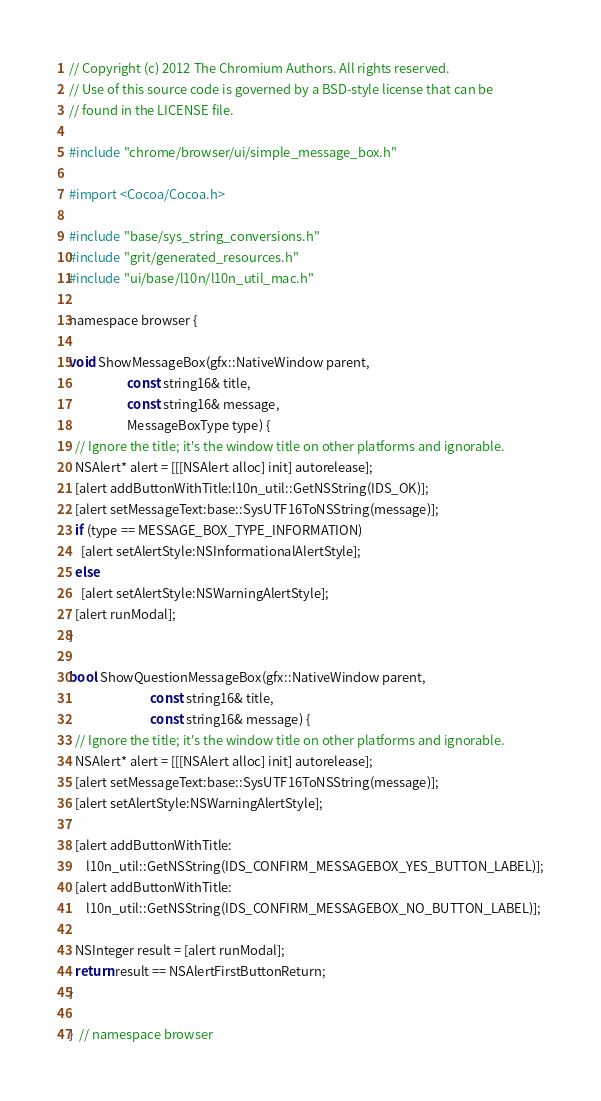Convert code to text. <code><loc_0><loc_0><loc_500><loc_500><_ObjectiveC_>// Copyright (c) 2012 The Chromium Authors. All rights reserved.
// Use of this source code is governed by a BSD-style license that can be
// found in the LICENSE file.

#include "chrome/browser/ui/simple_message_box.h"

#import <Cocoa/Cocoa.h>

#include "base/sys_string_conversions.h"
#include "grit/generated_resources.h"
#include "ui/base/l10n/l10n_util_mac.h"

namespace browser {

void ShowMessageBox(gfx::NativeWindow parent,
                    const string16& title,
                    const string16& message,
                    MessageBoxType type) {
  // Ignore the title; it's the window title on other platforms and ignorable.
  NSAlert* alert = [[[NSAlert alloc] init] autorelease];
  [alert addButtonWithTitle:l10n_util::GetNSString(IDS_OK)];
  [alert setMessageText:base::SysUTF16ToNSString(message)];
  if (type == MESSAGE_BOX_TYPE_INFORMATION)
    [alert setAlertStyle:NSInformationalAlertStyle];
  else
    [alert setAlertStyle:NSWarningAlertStyle];
  [alert runModal];
}

bool ShowQuestionMessageBox(gfx::NativeWindow parent,
                            const string16& title,
                            const string16& message) {
  // Ignore the title; it's the window title on other platforms and ignorable.
  NSAlert* alert = [[[NSAlert alloc] init] autorelease];
  [alert setMessageText:base::SysUTF16ToNSString(message)];
  [alert setAlertStyle:NSWarningAlertStyle];

  [alert addButtonWithTitle:
      l10n_util::GetNSString(IDS_CONFIRM_MESSAGEBOX_YES_BUTTON_LABEL)];
  [alert addButtonWithTitle:
      l10n_util::GetNSString(IDS_CONFIRM_MESSAGEBOX_NO_BUTTON_LABEL)];

  NSInteger result = [alert runModal];
  return result == NSAlertFirstButtonReturn;
}

}  // namespace browser
</code> 